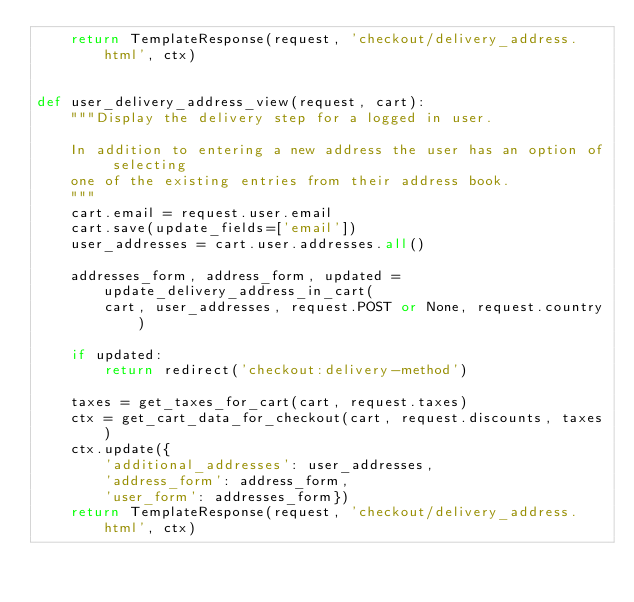<code> <loc_0><loc_0><loc_500><loc_500><_Python_>    return TemplateResponse(request, 'checkout/delivery_address.html', ctx)


def user_delivery_address_view(request, cart):
    """Display the delivery step for a logged in user.

    In addition to entering a new address the user has an option of selecting
    one of the existing entries from their address book.
    """
    cart.email = request.user.email
    cart.save(update_fields=['email'])
    user_addresses = cart.user.addresses.all()

    addresses_form, address_form, updated = update_delivery_address_in_cart(
        cart, user_addresses, request.POST or None, request.country)

    if updated:
        return redirect('checkout:delivery-method')

    taxes = get_taxes_for_cart(cart, request.taxes)
    ctx = get_cart_data_for_checkout(cart, request.discounts, taxes)
    ctx.update({
        'additional_addresses': user_addresses,
        'address_form': address_form,
        'user_form': addresses_form})
    return TemplateResponse(request, 'checkout/delivery_address.html', ctx)
</code> 